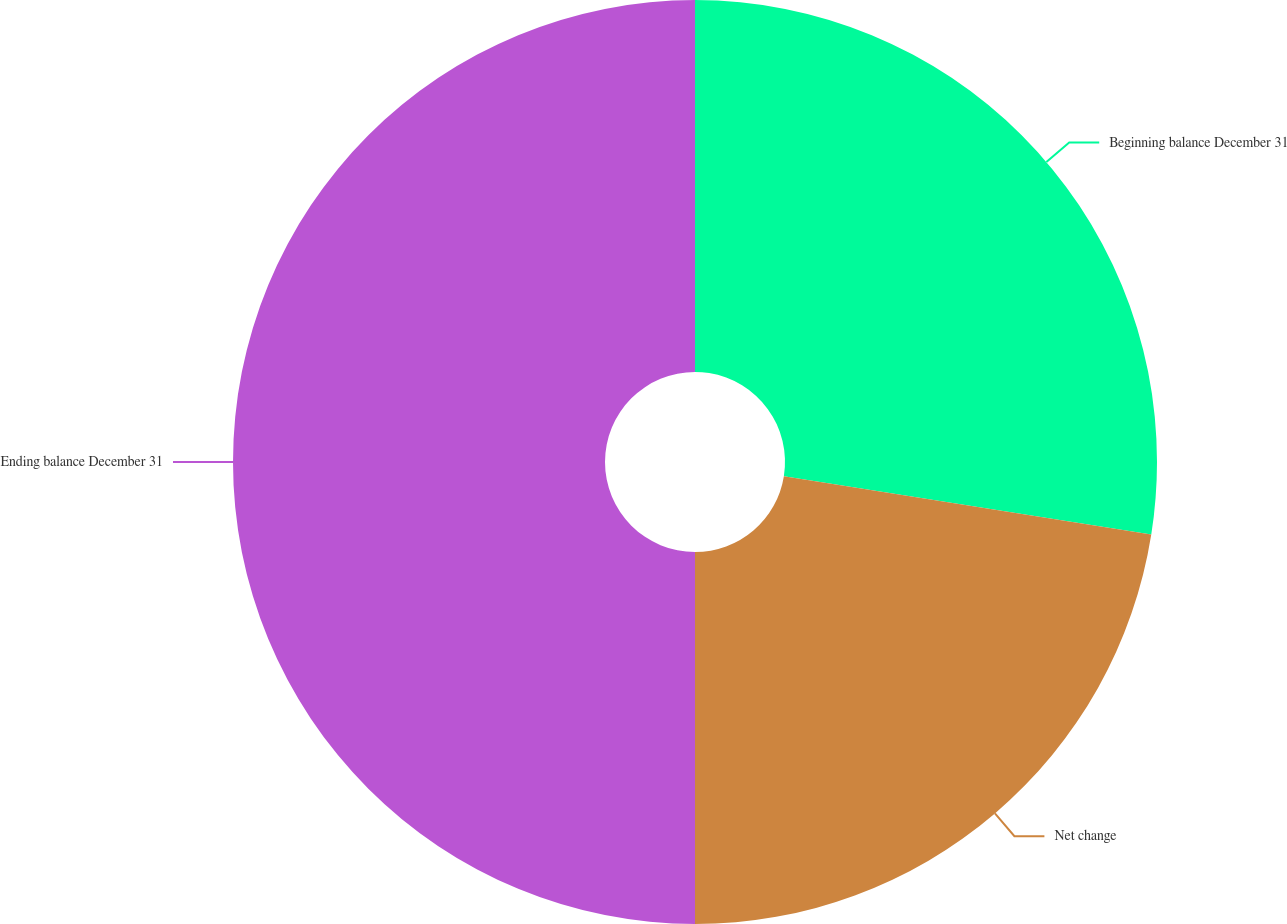Convert chart to OTSL. <chart><loc_0><loc_0><loc_500><loc_500><pie_chart><fcel>Beginning balance December 31<fcel>Net change<fcel>Ending balance December 31<nl><fcel>27.51%<fcel>22.49%<fcel>50.0%<nl></chart> 